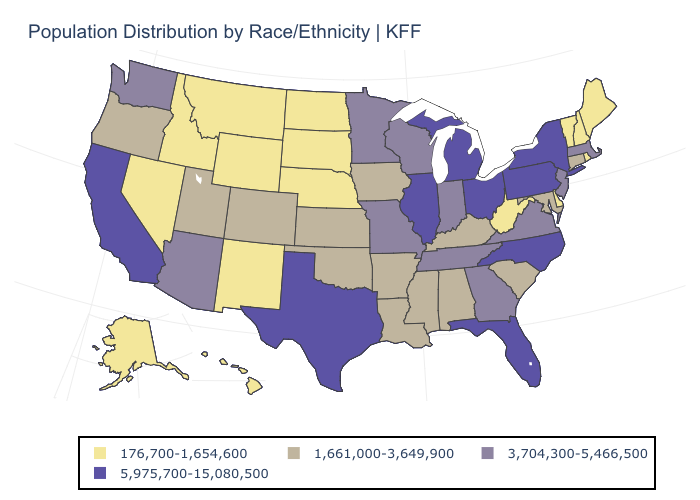What is the lowest value in the Northeast?
Quick response, please. 176,700-1,654,600. Is the legend a continuous bar?
Keep it brief. No. Does the first symbol in the legend represent the smallest category?
Keep it brief. Yes. Does the map have missing data?
Write a very short answer. No. Does the first symbol in the legend represent the smallest category?
Keep it brief. Yes. Does Florida have the lowest value in the USA?
Keep it brief. No. What is the value of Oklahoma?
Write a very short answer. 1,661,000-3,649,900. What is the lowest value in the USA?
Write a very short answer. 176,700-1,654,600. Among the states that border Vermont , which have the highest value?
Short answer required. New York. Name the states that have a value in the range 5,975,700-15,080,500?
Keep it brief. California, Florida, Illinois, Michigan, New York, North Carolina, Ohio, Pennsylvania, Texas. What is the value of Montana?
Short answer required. 176,700-1,654,600. Name the states that have a value in the range 5,975,700-15,080,500?
Short answer required. California, Florida, Illinois, Michigan, New York, North Carolina, Ohio, Pennsylvania, Texas. Does Idaho have the lowest value in the USA?
Answer briefly. Yes. Does Delaware have the lowest value in the South?
Give a very brief answer. Yes. What is the value of Missouri?
Concise answer only. 3,704,300-5,466,500. 